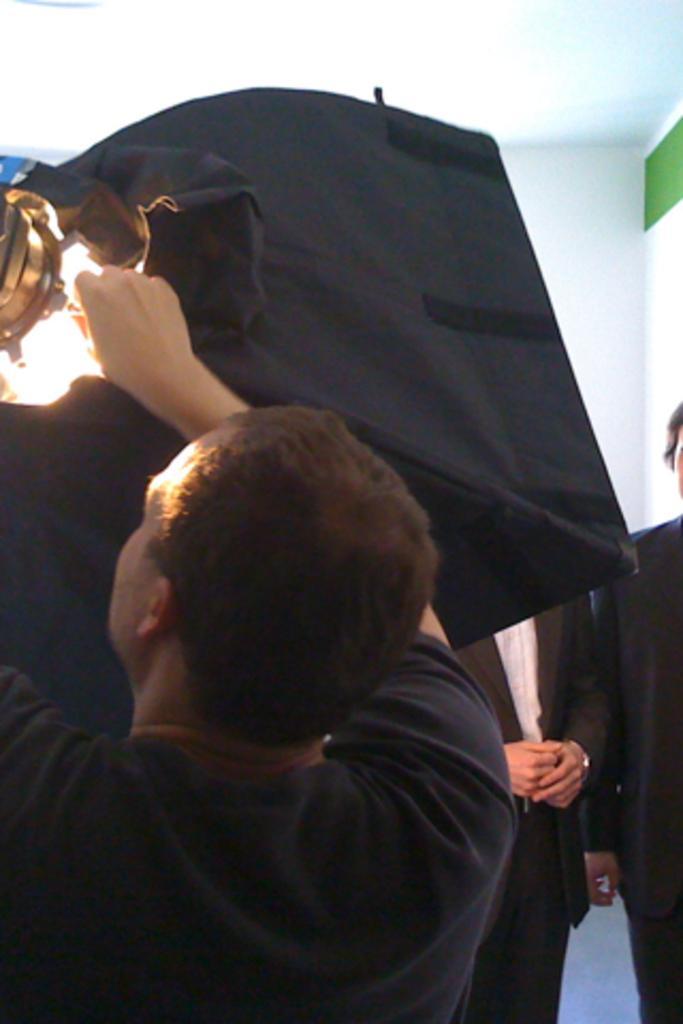Please provide a concise description of this image. In this image there are a few men. The man in the foreground is holding an object. In the top right there is a light. At the top there is the ceiling. 